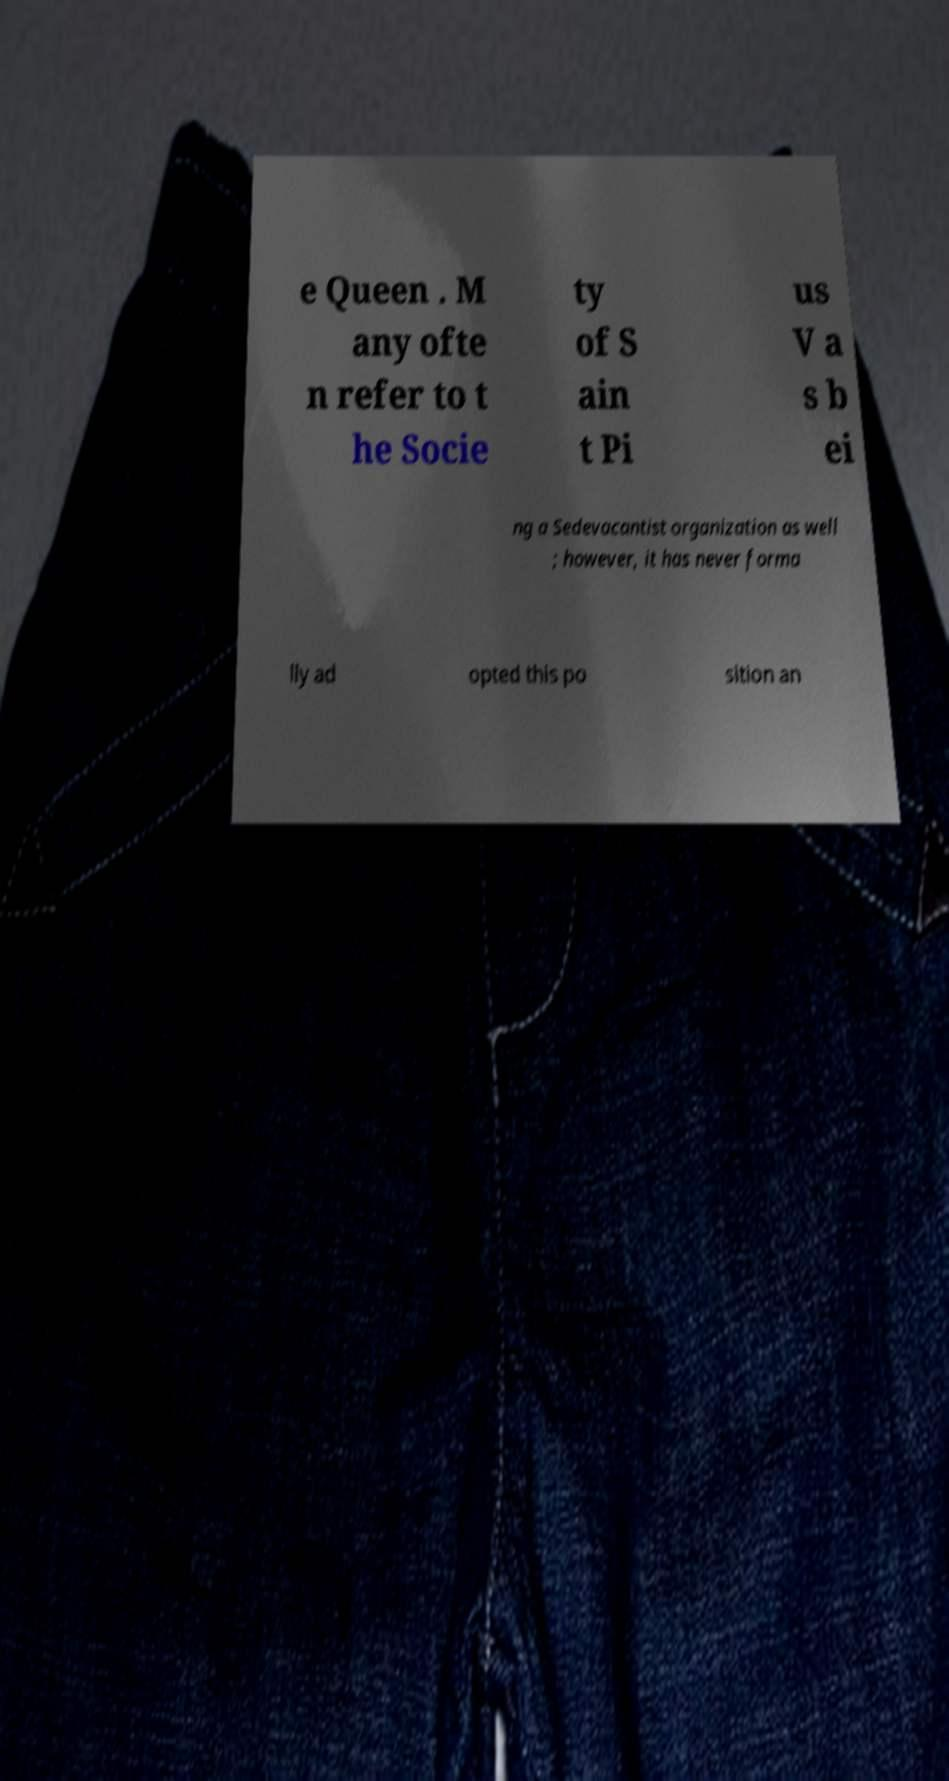I need the written content from this picture converted into text. Can you do that? e Queen . M any ofte n refer to t he Socie ty of S ain t Pi us V a s b ei ng a Sedevacantist organization as well ; however, it has never forma lly ad opted this po sition an 